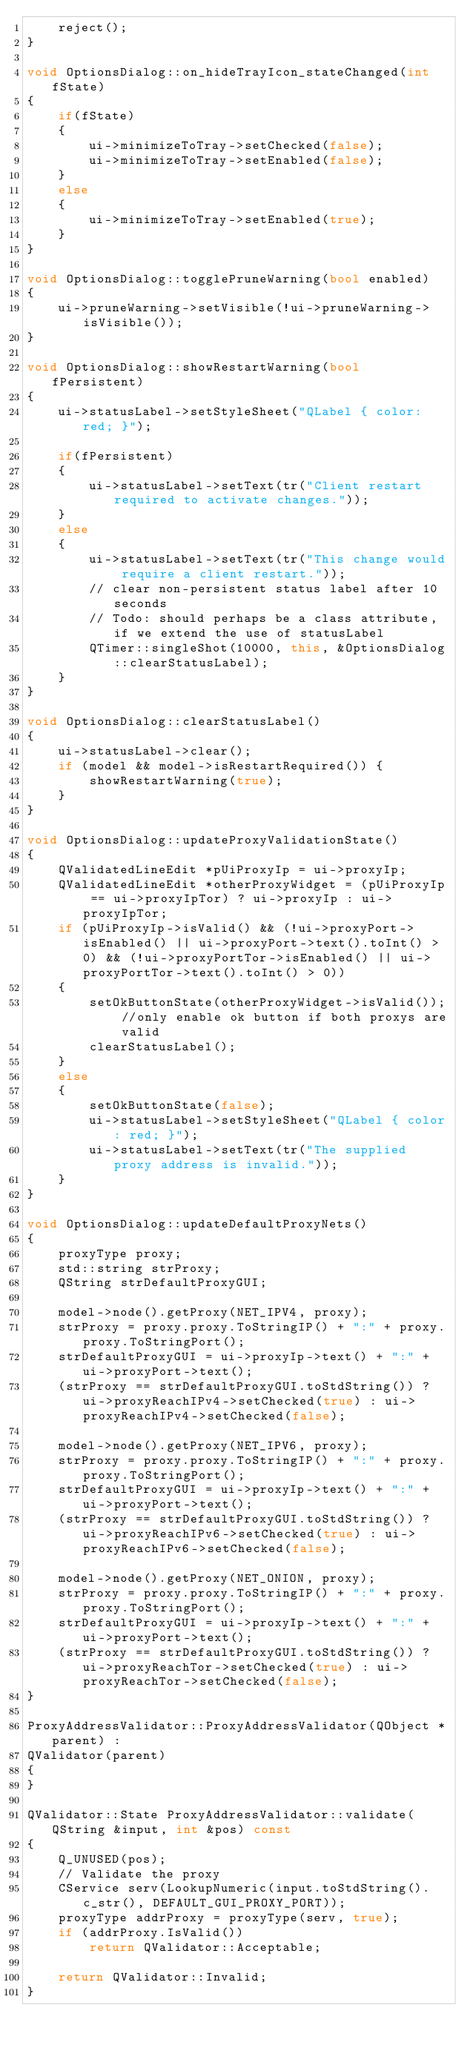Convert code to text. <code><loc_0><loc_0><loc_500><loc_500><_C++_>    reject();
}

void OptionsDialog::on_hideTrayIcon_stateChanged(int fState)
{
    if(fState)
    {
        ui->minimizeToTray->setChecked(false);
        ui->minimizeToTray->setEnabled(false);
    }
    else
    {
        ui->minimizeToTray->setEnabled(true);
    }
}

void OptionsDialog::togglePruneWarning(bool enabled)
{
    ui->pruneWarning->setVisible(!ui->pruneWarning->isVisible());
}

void OptionsDialog::showRestartWarning(bool fPersistent)
{
    ui->statusLabel->setStyleSheet("QLabel { color: red; }");

    if(fPersistent)
    {
        ui->statusLabel->setText(tr("Client restart required to activate changes."));
    }
    else
    {
        ui->statusLabel->setText(tr("This change would require a client restart."));
        // clear non-persistent status label after 10 seconds
        // Todo: should perhaps be a class attribute, if we extend the use of statusLabel
        QTimer::singleShot(10000, this, &OptionsDialog::clearStatusLabel);
    }
}

void OptionsDialog::clearStatusLabel()
{
    ui->statusLabel->clear();
    if (model && model->isRestartRequired()) {
        showRestartWarning(true);
    }
}

void OptionsDialog::updateProxyValidationState()
{
    QValidatedLineEdit *pUiProxyIp = ui->proxyIp;
    QValidatedLineEdit *otherProxyWidget = (pUiProxyIp == ui->proxyIpTor) ? ui->proxyIp : ui->proxyIpTor;
    if (pUiProxyIp->isValid() && (!ui->proxyPort->isEnabled() || ui->proxyPort->text().toInt() > 0) && (!ui->proxyPortTor->isEnabled() || ui->proxyPortTor->text().toInt() > 0))
    {
        setOkButtonState(otherProxyWidget->isValid()); //only enable ok button if both proxys are valid
        clearStatusLabel();
    }
    else
    {
        setOkButtonState(false);
        ui->statusLabel->setStyleSheet("QLabel { color: red; }");
        ui->statusLabel->setText(tr("The supplied proxy address is invalid."));
    }
}

void OptionsDialog::updateDefaultProxyNets()
{
    proxyType proxy;
    std::string strProxy;
    QString strDefaultProxyGUI;

    model->node().getProxy(NET_IPV4, proxy);
    strProxy = proxy.proxy.ToStringIP() + ":" + proxy.proxy.ToStringPort();
    strDefaultProxyGUI = ui->proxyIp->text() + ":" + ui->proxyPort->text();
    (strProxy == strDefaultProxyGUI.toStdString()) ? ui->proxyReachIPv4->setChecked(true) : ui->proxyReachIPv4->setChecked(false);

    model->node().getProxy(NET_IPV6, proxy);
    strProxy = proxy.proxy.ToStringIP() + ":" + proxy.proxy.ToStringPort();
    strDefaultProxyGUI = ui->proxyIp->text() + ":" + ui->proxyPort->text();
    (strProxy == strDefaultProxyGUI.toStdString()) ? ui->proxyReachIPv6->setChecked(true) : ui->proxyReachIPv6->setChecked(false);

    model->node().getProxy(NET_ONION, proxy);
    strProxy = proxy.proxy.ToStringIP() + ":" + proxy.proxy.ToStringPort();
    strDefaultProxyGUI = ui->proxyIp->text() + ":" + ui->proxyPort->text();
    (strProxy == strDefaultProxyGUI.toStdString()) ? ui->proxyReachTor->setChecked(true) : ui->proxyReachTor->setChecked(false);
}

ProxyAddressValidator::ProxyAddressValidator(QObject *parent) :
QValidator(parent)
{
}

QValidator::State ProxyAddressValidator::validate(QString &input, int &pos) const
{
    Q_UNUSED(pos);
    // Validate the proxy
    CService serv(LookupNumeric(input.toStdString().c_str(), DEFAULT_GUI_PROXY_PORT));
    proxyType addrProxy = proxyType(serv, true);
    if (addrProxy.IsValid())
        return QValidator::Acceptable;

    return QValidator::Invalid;
}
</code> 